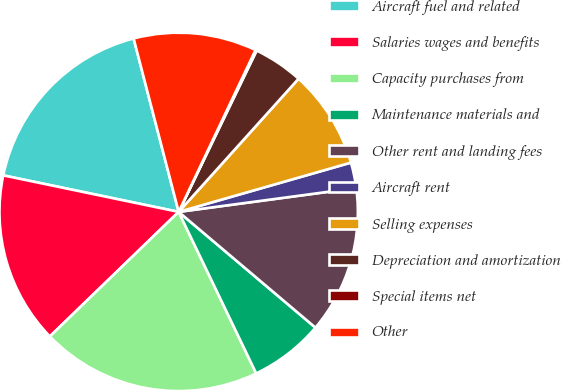<chart> <loc_0><loc_0><loc_500><loc_500><pie_chart><fcel>Aircraft fuel and related<fcel>Salaries wages and benefits<fcel>Capacity purchases from<fcel>Maintenance materials and<fcel>Other rent and landing fees<fcel>Aircraft rent<fcel>Selling expenses<fcel>Depreciation and amortization<fcel>Special items net<fcel>Other<nl><fcel>17.69%<fcel>15.5%<fcel>19.89%<fcel>6.7%<fcel>13.3%<fcel>2.31%<fcel>8.9%<fcel>4.5%<fcel>0.11%<fcel>11.1%<nl></chart> 